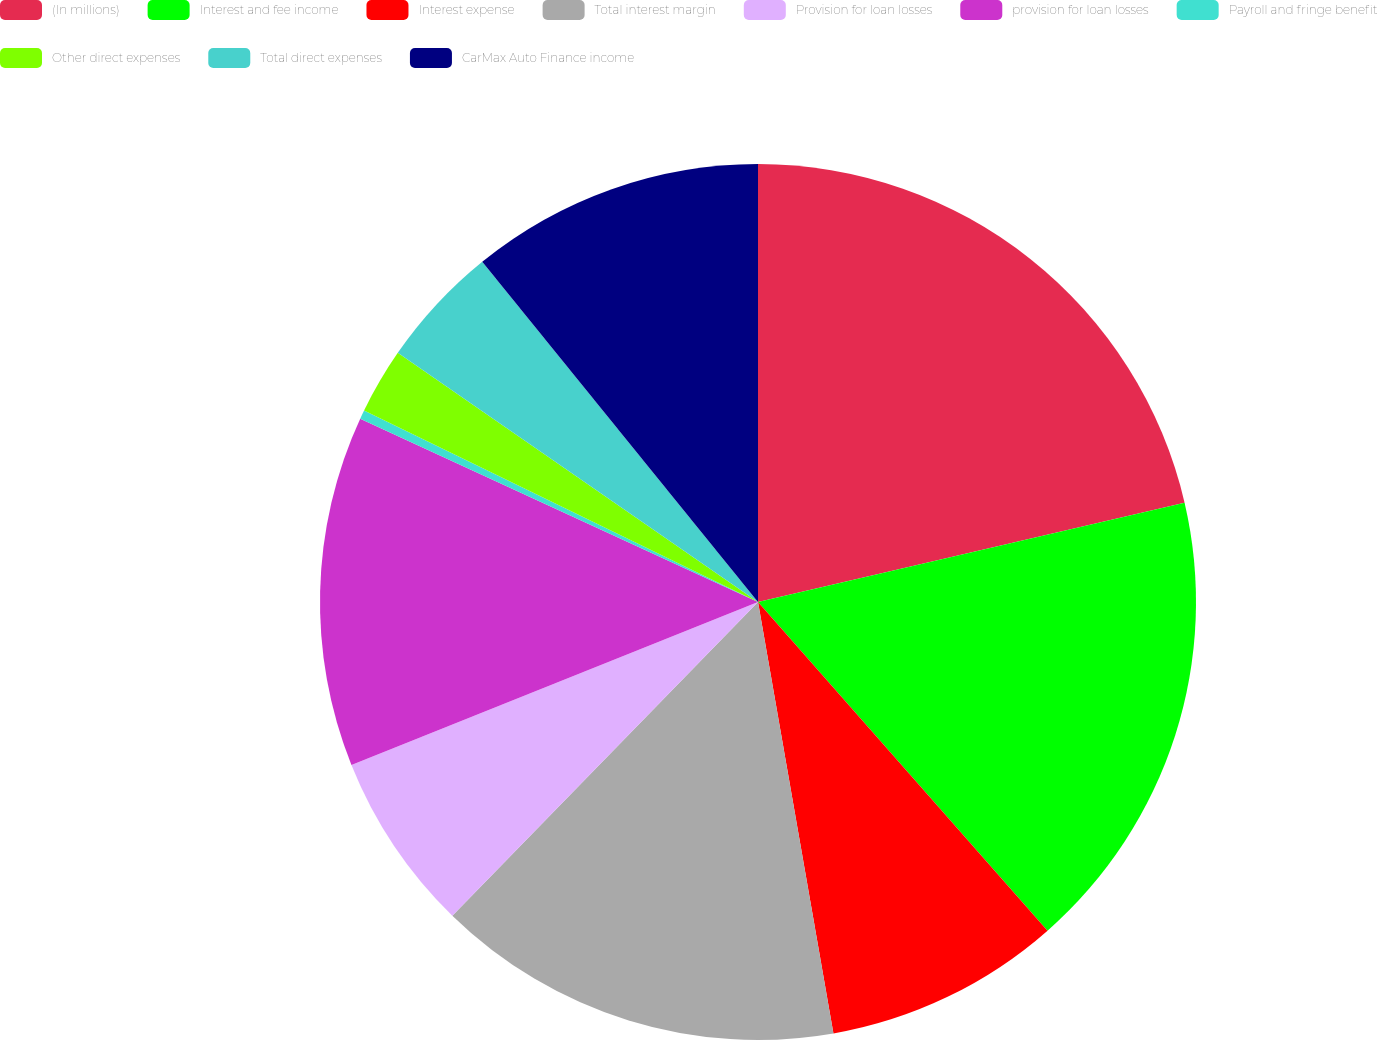Convert chart. <chart><loc_0><loc_0><loc_500><loc_500><pie_chart><fcel>(In millions)<fcel>Interest and fee income<fcel>Interest expense<fcel>Total interest margin<fcel>Provision for loan losses<fcel>provision for loan losses<fcel>Payroll and fringe benefit<fcel>Other direct expenses<fcel>Total direct expenses<fcel>CarMax Auto Finance income<nl><fcel>21.36%<fcel>17.15%<fcel>8.74%<fcel>15.05%<fcel>6.64%<fcel>12.94%<fcel>0.33%<fcel>2.43%<fcel>4.53%<fcel>10.84%<nl></chart> 